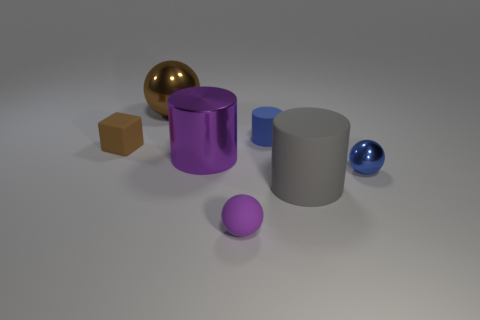Add 1 small gray matte balls. How many objects exist? 8 Subtract all big shiny cylinders. How many cylinders are left? 2 Subtract all purple cylinders. How many cylinders are left? 2 Subtract 2 cylinders. How many cylinders are left? 1 Subtract all cylinders. How many objects are left? 4 Add 6 gray objects. How many gray objects are left? 7 Add 1 brown objects. How many brown objects exist? 3 Subtract 1 brown blocks. How many objects are left? 6 Subtract all green blocks. Subtract all brown cylinders. How many blocks are left? 1 Subtract all yellow spheres. How many green cylinders are left? 0 